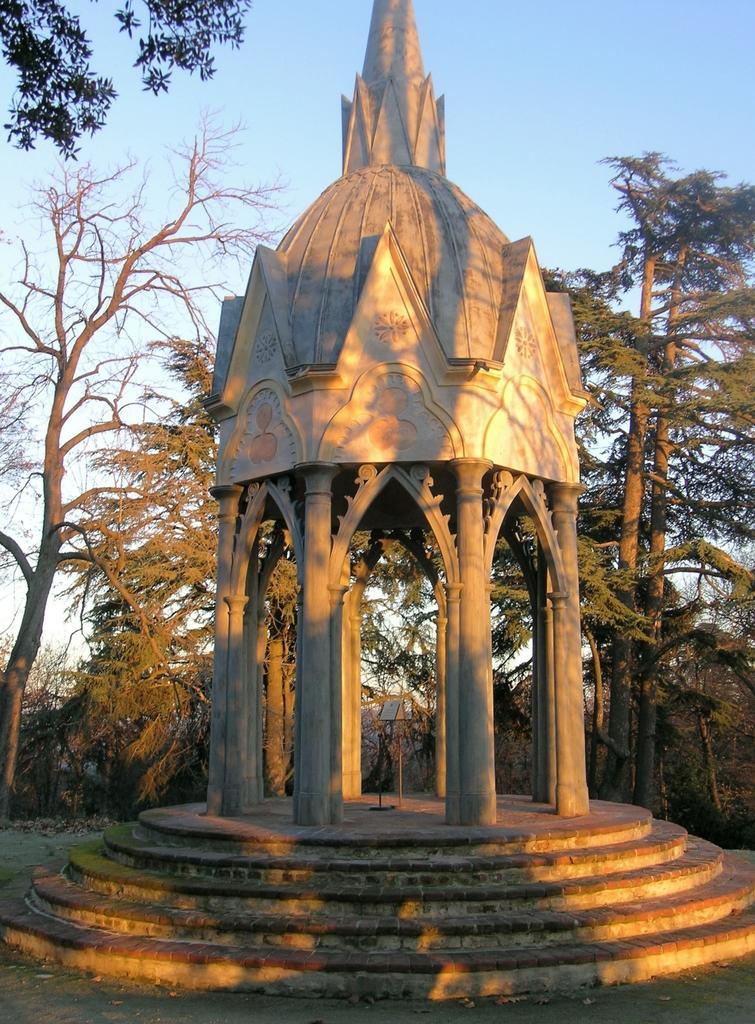Can you describe this image briefly? In this image I can see a gazebo. There are trees and in the background there is sky. 